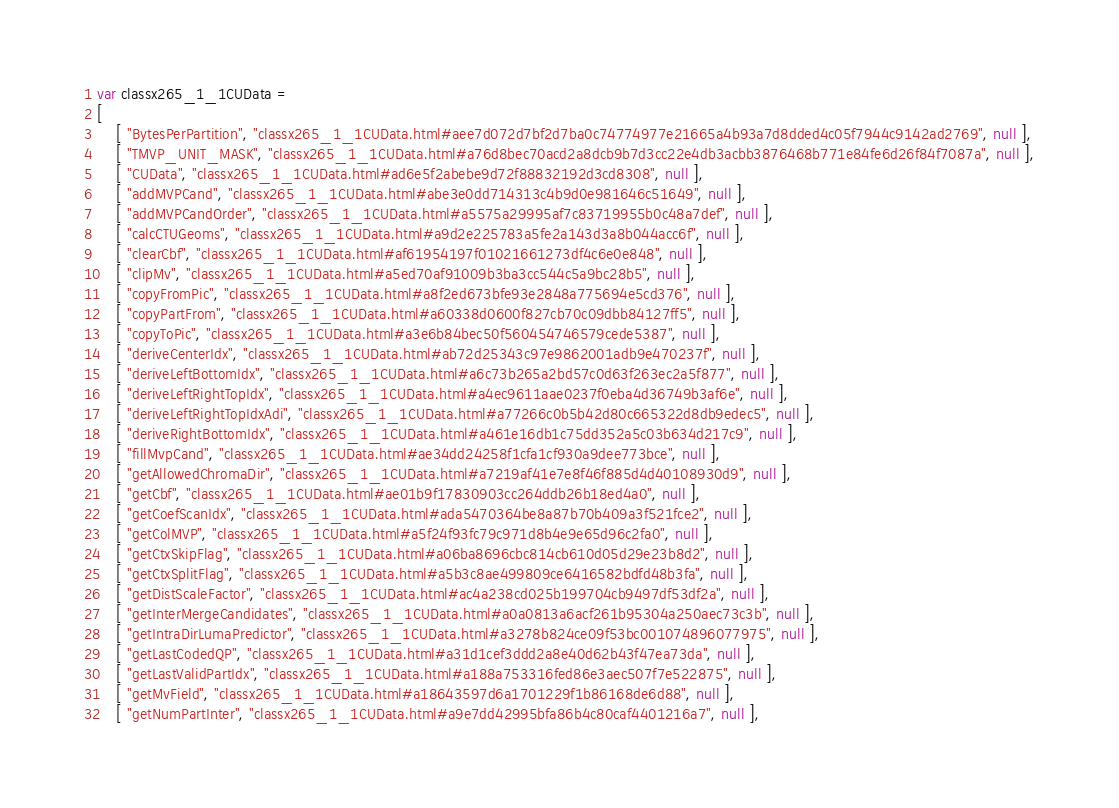Convert code to text. <code><loc_0><loc_0><loc_500><loc_500><_JavaScript_>var classx265_1_1CUData =
[
    [ "BytesPerPartition", "classx265_1_1CUData.html#aee7d072d7bf2d7ba0c74774977e21665a4b93a7d8dded4c05f7944c9142ad2769", null ],
    [ "TMVP_UNIT_MASK", "classx265_1_1CUData.html#a76d8bec70acd2a8dcb9b7d3cc22e4db3acbb3876468b771e84fe6d26f84f7087a", null ],
    [ "CUData", "classx265_1_1CUData.html#ad6e5f2abebe9d72f88832192d3cd8308", null ],
    [ "addMVPCand", "classx265_1_1CUData.html#abe3e0dd714313c4b9d0e981646c51649", null ],
    [ "addMVPCandOrder", "classx265_1_1CUData.html#a5575a29995af7c83719955b0c48a7def", null ],
    [ "calcCTUGeoms", "classx265_1_1CUData.html#a9d2e225783a5fe2a143d3a8b044acc6f", null ],
    [ "clearCbf", "classx265_1_1CUData.html#af61954197f01021661273df4c6e0e848", null ],
    [ "clipMv", "classx265_1_1CUData.html#a5ed70af91009b3ba3cc544c5a9bc28b5", null ],
    [ "copyFromPic", "classx265_1_1CUData.html#a8f2ed673bfe93e2848a775694e5cd376", null ],
    [ "copyPartFrom", "classx265_1_1CUData.html#a60338d0600f827cb70c09dbb84127ff5", null ],
    [ "copyToPic", "classx265_1_1CUData.html#a3e6b84bec50f560454746579cede5387", null ],
    [ "deriveCenterIdx", "classx265_1_1CUData.html#ab72d25343c97e9862001adb9e470237f", null ],
    [ "deriveLeftBottomIdx", "classx265_1_1CUData.html#a6c73b265a2bd57c0d63f263ec2a5f877", null ],
    [ "deriveLeftRightTopIdx", "classx265_1_1CUData.html#a4ec9611aae0237f0eba4d36749b3af6e", null ],
    [ "deriveLeftRightTopIdxAdi", "classx265_1_1CUData.html#a77266c0b5b42d80c665322d8db9edec5", null ],
    [ "deriveRightBottomIdx", "classx265_1_1CUData.html#a461e16db1c75dd352a5c03b634d217c9", null ],
    [ "fillMvpCand", "classx265_1_1CUData.html#ae34dd24258f1cfa1cf930a9dee773bce", null ],
    [ "getAllowedChromaDir", "classx265_1_1CUData.html#a7219af41e7e8f46f885d4d40108930d9", null ],
    [ "getCbf", "classx265_1_1CUData.html#ae01b9f17830903cc264ddb26b18ed4a0", null ],
    [ "getCoefScanIdx", "classx265_1_1CUData.html#ada5470364be8a87b70b409a3f521fce2", null ],
    [ "getColMVP", "classx265_1_1CUData.html#a5f24f93fc79c971d8b4e9e65d96c2fa0", null ],
    [ "getCtxSkipFlag", "classx265_1_1CUData.html#a06ba8696cbc814cb610d05d29e23b8d2", null ],
    [ "getCtxSplitFlag", "classx265_1_1CUData.html#a5b3c8ae499809ce6416582bdfd48b3fa", null ],
    [ "getDistScaleFactor", "classx265_1_1CUData.html#ac4a238cd025b199704cb9497df53df2a", null ],
    [ "getInterMergeCandidates", "classx265_1_1CUData.html#a0a0813a6acf261b95304a250aec73c3b", null ],
    [ "getIntraDirLumaPredictor", "classx265_1_1CUData.html#a3278b824ce09f53bc001074896077975", null ],
    [ "getLastCodedQP", "classx265_1_1CUData.html#a31d1cef3ddd2a8e40d62b43f47ea73da", null ],
    [ "getLastValidPartIdx", "classx265_1_1CUData.html#a188a753316fed86e3aec507f7e522875", null ],
    [ "getMvField", "classx265_1_1CUData.html#a18643597d6a1701229f1b86168de6d88", null ],
    [ "getNumPartInter", "classx265_1_1CUData.html#a9e7dd42995bfa86b4c80caf4401216a7", null ],</code> 